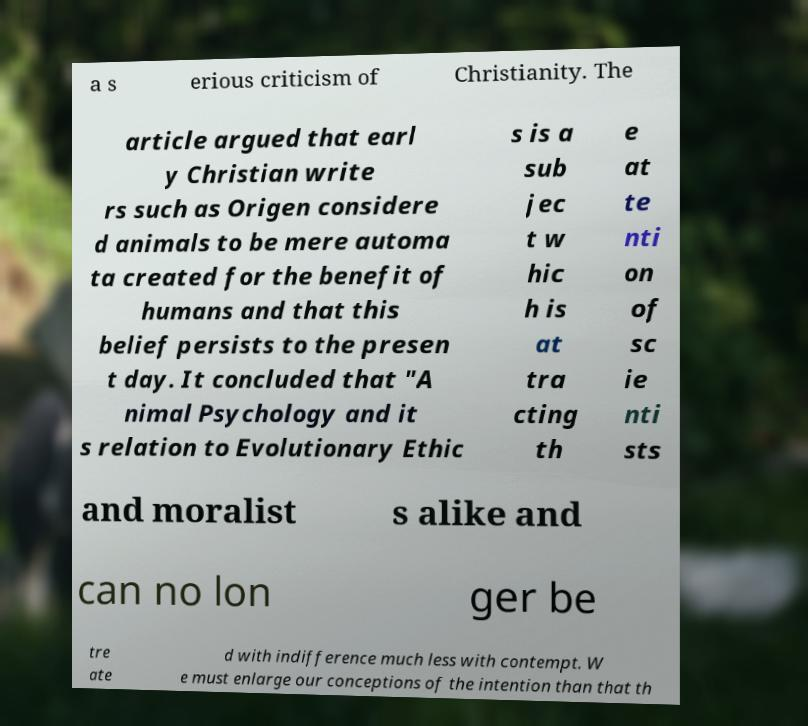Could you extract and type out the text from this image? a s erious criticism of Christianity. The article argued that earl y Christian write rs such as Origen considere d animals to be mere automa ta created for the benefit of humans and that this belief persists to the presen t day. It concluded that "A nimal Psychology and it s relation to Evolutionary Ethic s is a sub jec t w hic h is at tra cting th e at te nti on of sc ie nti sts and moralist s alike and can no lon ger be tre ate d with indifference much less with contempt. W e must enlarge our conceptions of the intention than that th 